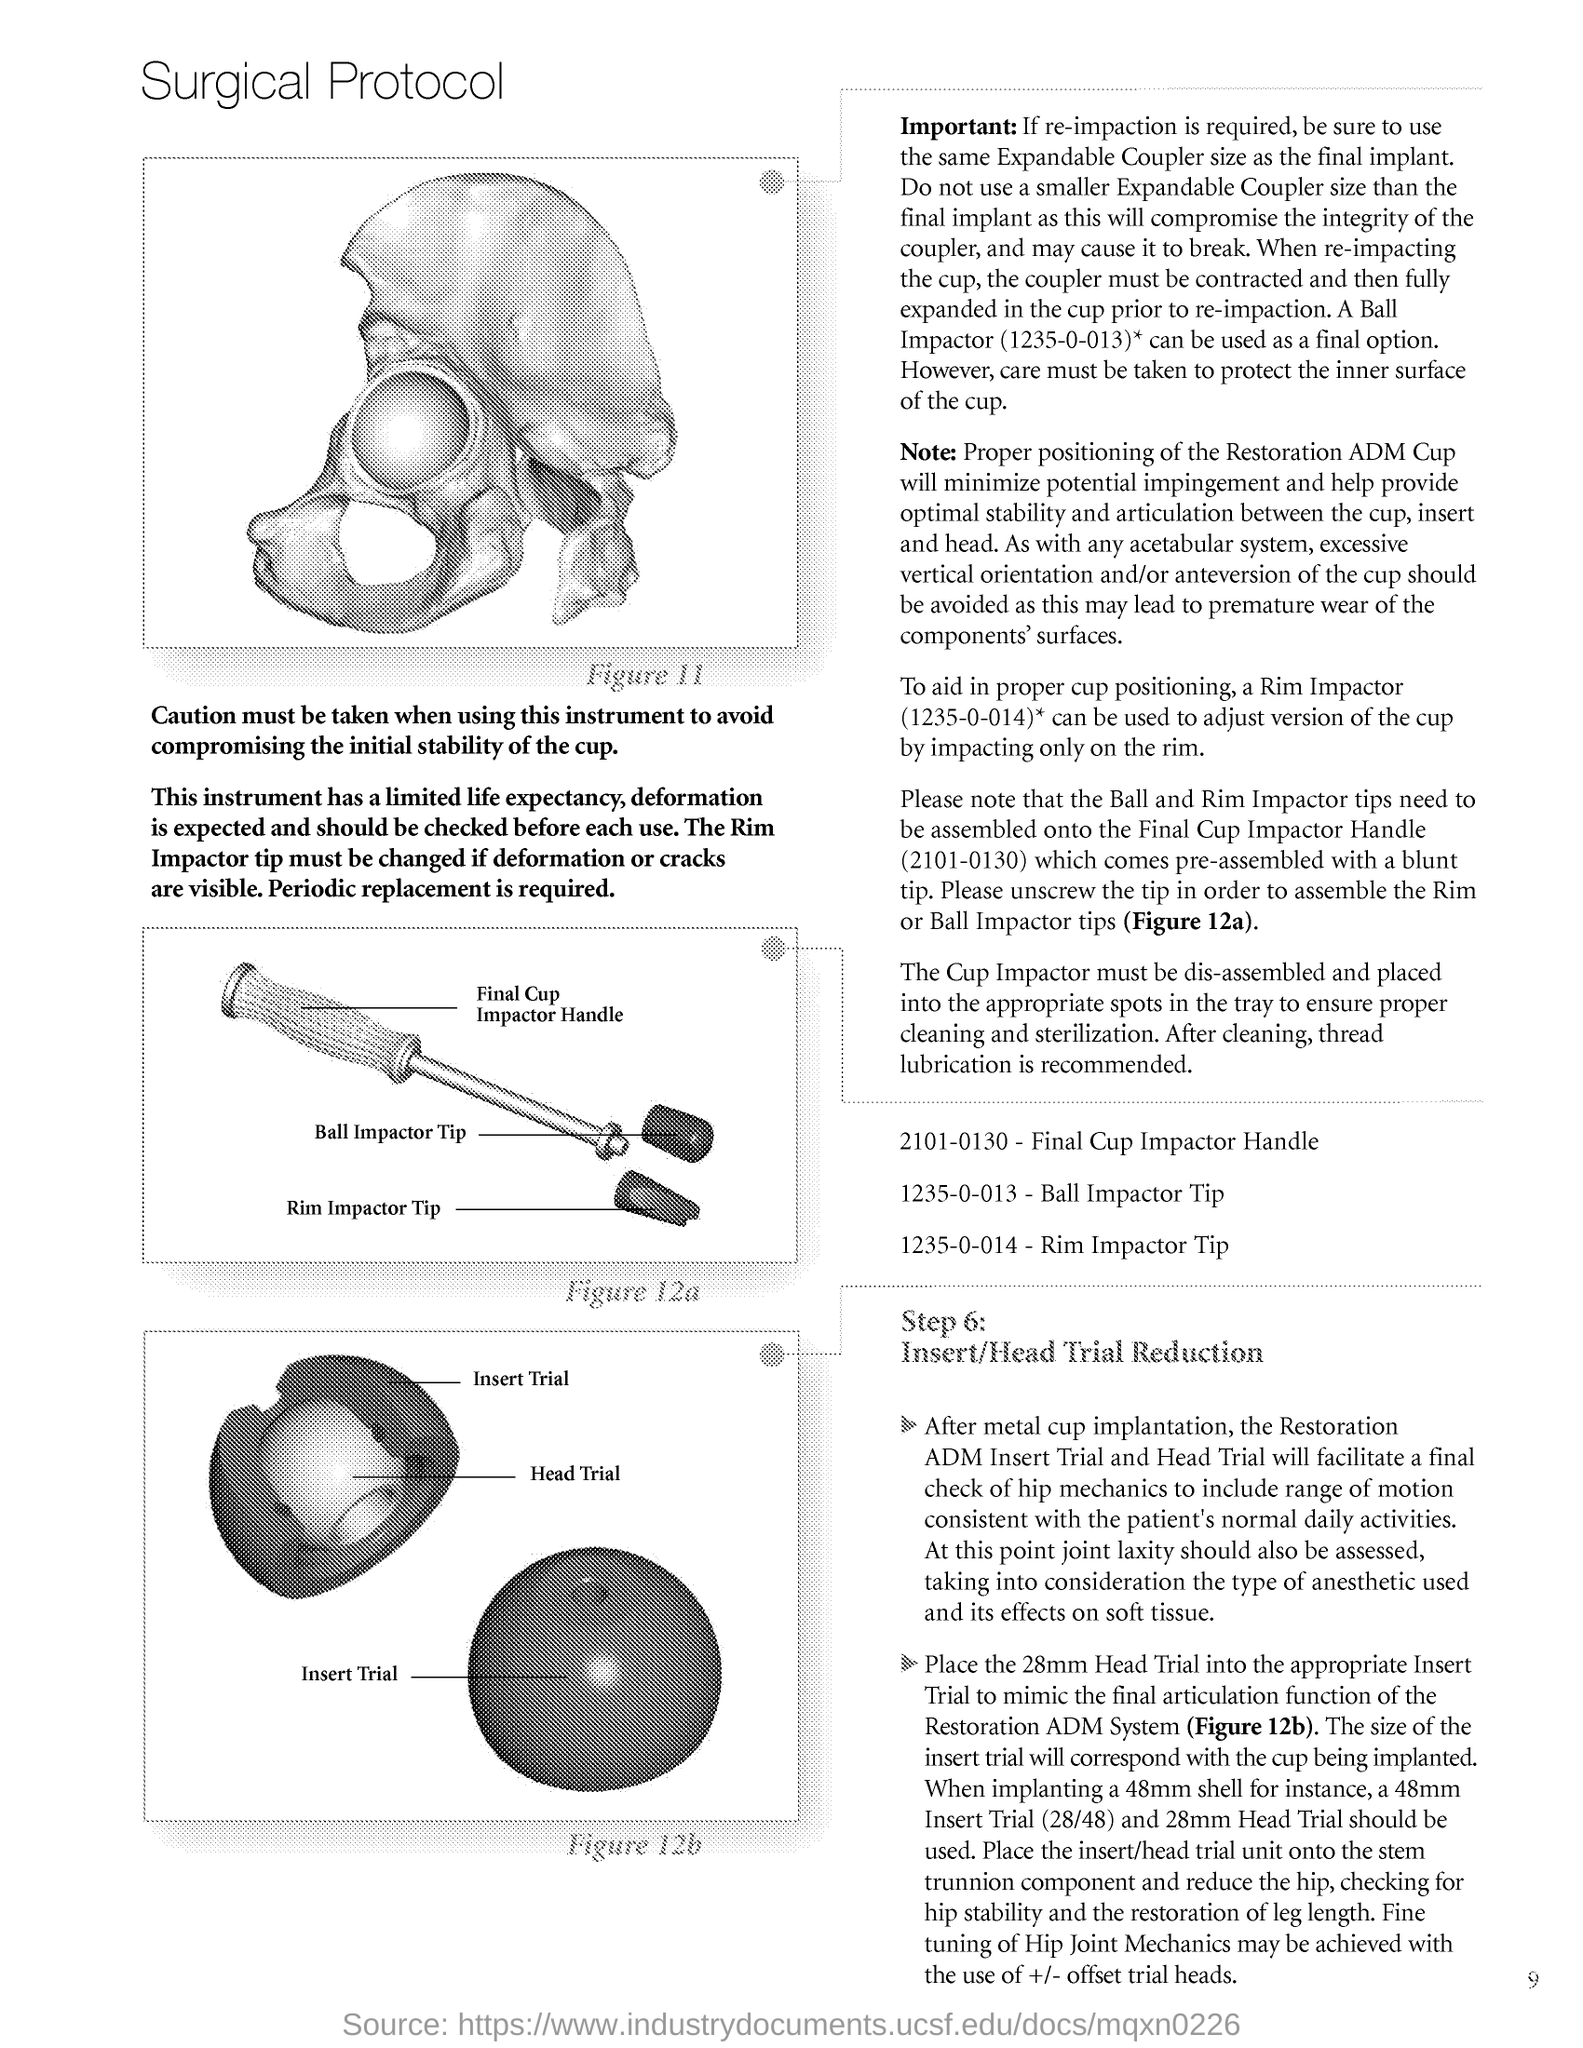Indicate a few pertinent items in this graphic. The title of the document is "Surgical Protocol. 